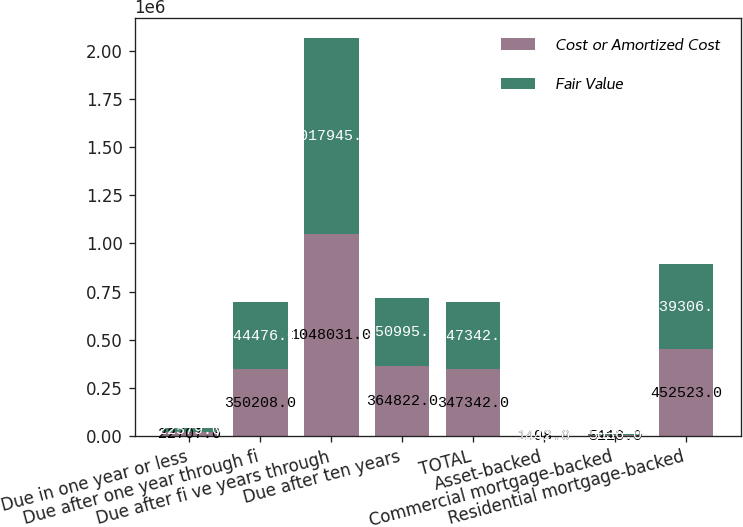Convert chart. <chart><loc_0><loc_0><loc_500><loc_500><stacked_bar_chart><ecel><fcel>Due in one year or less<fcel>Due after one year through fi<fcel>Due after fi ve years through<fcel>Due after ten years<fcel>TOTAL<fcel>Asset-backed<fcel>Commercial mortgage-backed<fcel>Residential mortgage-backed<nl><fcel>Cost or Amortized Cost<fcel>22707<fcel>350208<fcel>1.04803e+06<fcel>364822<fcel>347342<fcel>1498<fcel>5118<fcel>452523<nl><fcel>Fair Value<fcel>22579<fcel>344476<fcel>1.01794e+06<fcel>350995<fcel>347342<fcel>1442<fcel>5036<fcel>439306<nl></chart> 